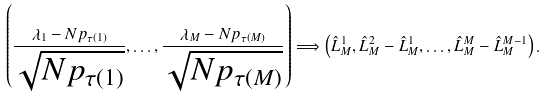<formula> <loc_0><loc_0><loc_500><loc_500>\left ( \frac { \lambda _ { 1 } - N p _ { \tau ( 1 ) } } { \sqrt { N p _ { \tau ( 1 ) } } } , \dots , \frac { \lambda _ { M } - N p _ { \tau ( M ) } } { \sqrt { N p _ { \tau ( M ) } } } \right ) \Longrightarrow \left ( \hat { L } _ { M } ^ { 1 } , \hat { L } _ { M } ^ { 2 } - \hat { L } _ { M } ^ { 1 } , \dots , \hat { L } _ { M } ^ { M } - \hat { L } _ { M } ^ { M - 1 } \right ) .</formula> 